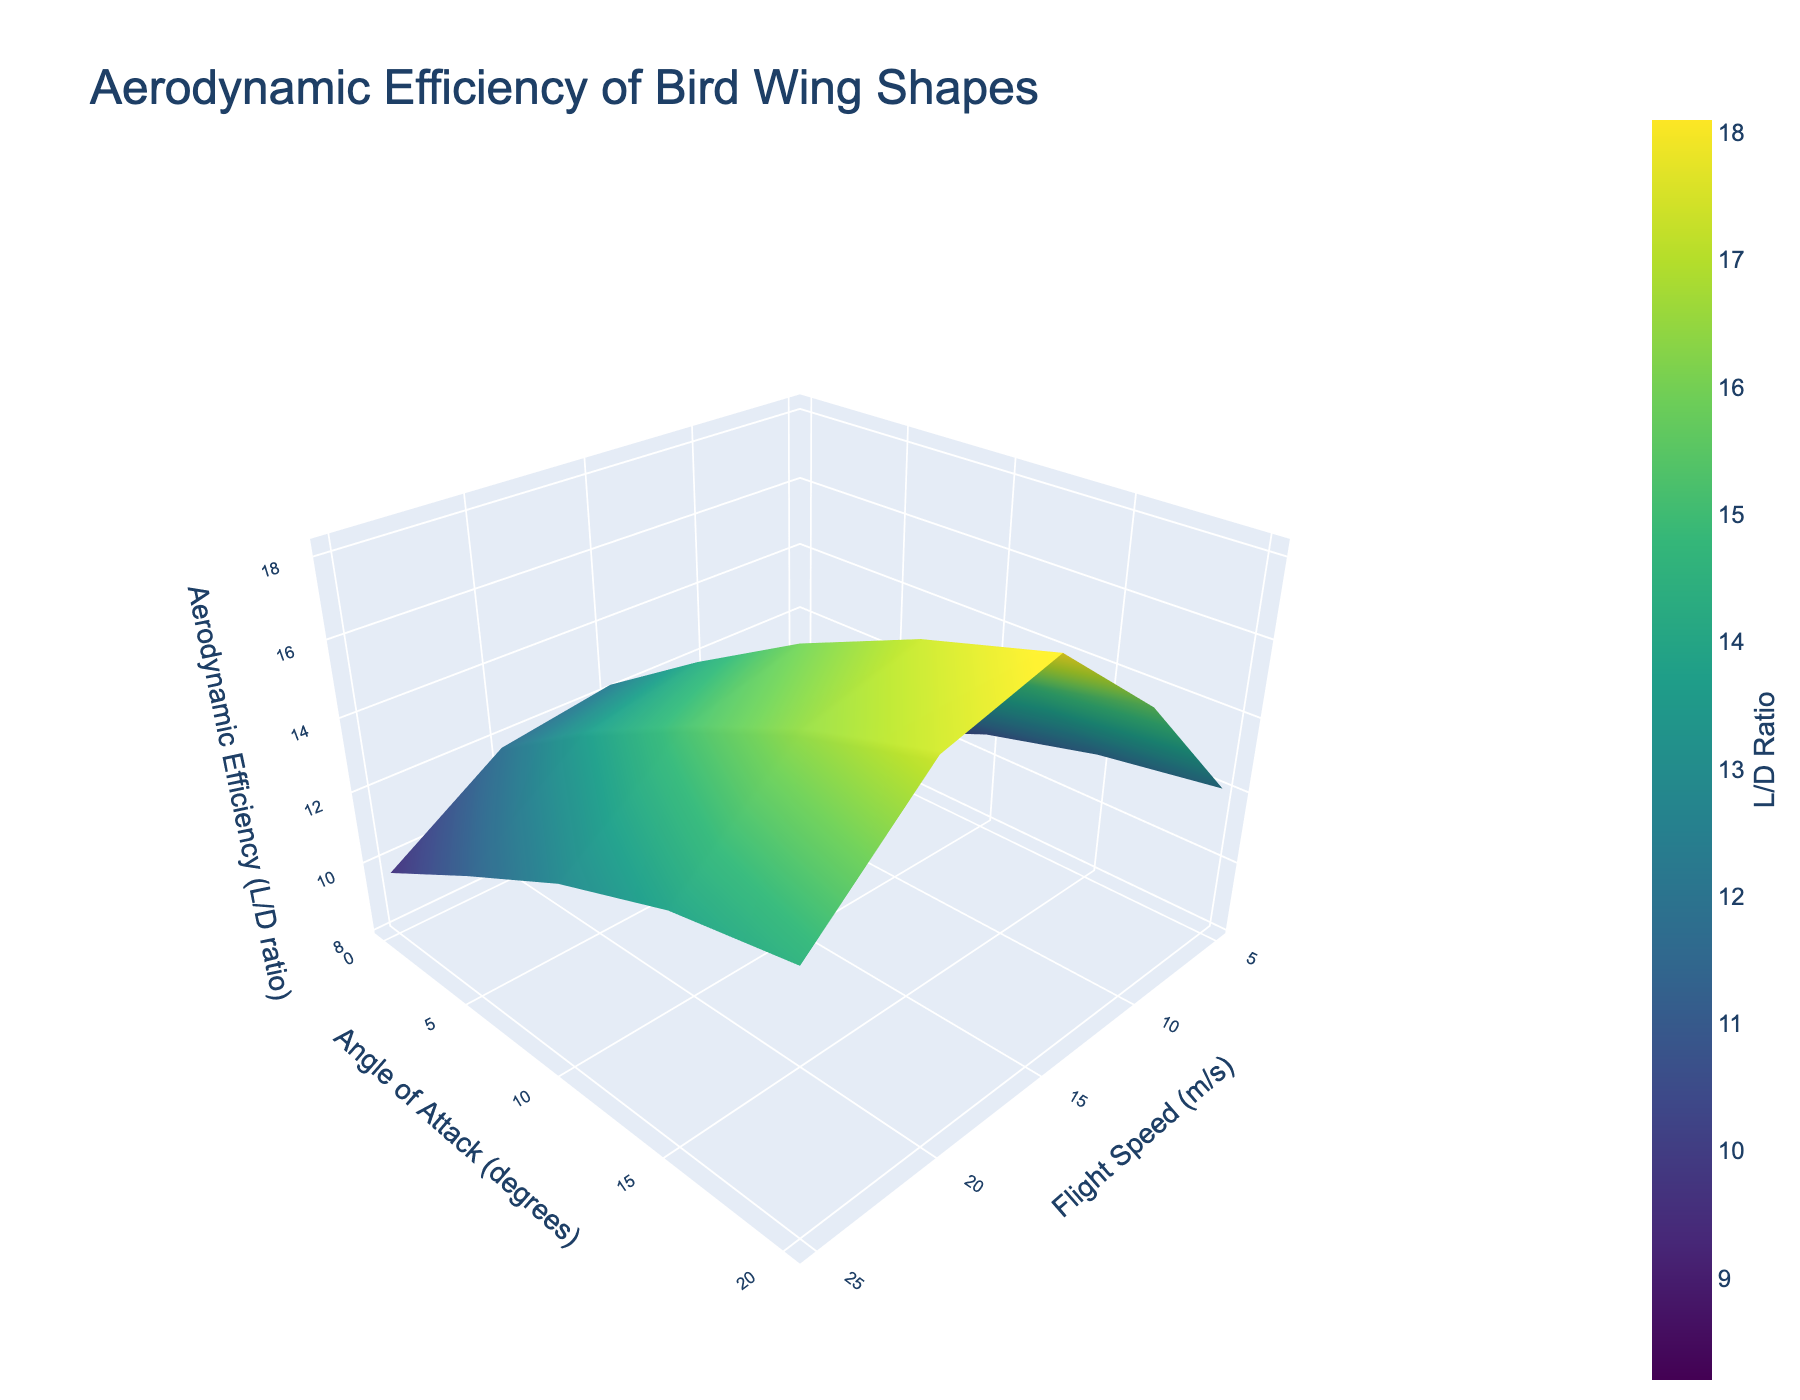What's the title of the plot? The title of the plot is positioned at the top and is usually the most prominent piece of text.
Answer: Aerodynamic Efficiency of Bird Wing Shapes What are the axes labels? The axes labels describe the data dimensions, found next to each axis.
Answer: The x-axis is labeled 'Flight Speed (m/s)', the y-axis is labeled 'Angle of Attack (degrees)', and the z-axis is labeled 'Aerodynamic Efficiency (L/D ratio)' Which color scale is used in the plot? The color scale represents variations in aerodynamic efficiency and is usually distinct and labeled in the legend.
Answer: Viridis At what flight speed and angle of attack is the maximum aerodynamic efficiency observed? This involves finding the highest point on the 3D surface plot and noting the corresponding x and y values.
Answer: At 25 m/s flight speed and 10 degrees angle of attack How does the aerodynamic efficiency change as flight speed increases from 5 m/s to 25 m/s at 10 degrees angle of attack? Observe the z-values along the fixed angle of attack (10 degrees) line and note the changes.
Answer: Efficiency increases from 12.3 to 18.1 What is the difference in aerodynamic efficiency between 15 degrees and 20 degrees angle of attack at 10 m/s flight speed? Subtract the z-value at 20 degrees from the z-value at 15 degrees for 10 m/s flight speed.
Answer: 13.6 - 11.3 = 2.3 Is there a general trend in aerodynamic efficiency with increasing angles of attack at a constant flight speed? Observe the variation in z-values as the angle of attack increases for any given flight speed.
Answer: Efficiency generally increases until around 10 degrees, then decreases At which angle of attack do we observe the least aerodynamic efficiency at 15 m/s flight speed? Locate the smallest z-value at 15 m/s and find the corresponding angle of attack.
Answer: 20 degrees, with an efficiency of 12.8 How does the colorbar help in interpreting the plot? The colorbar provides a visual reference to map colors to specific efficiency values, assisting in quick interpretation.
Answer: It shows the range and distribution of aerodynamic efficiencies using the Viridis color scale Which combination of flight speed and angle of attack provides a relatively stable aerodynamic efficiency? Compare the z-values across various pairs of flight speed and angles, looking for minimal fluctuation.
Answer: Around 15 m/s flight speed and 10 to 15 degrees angle of attack 